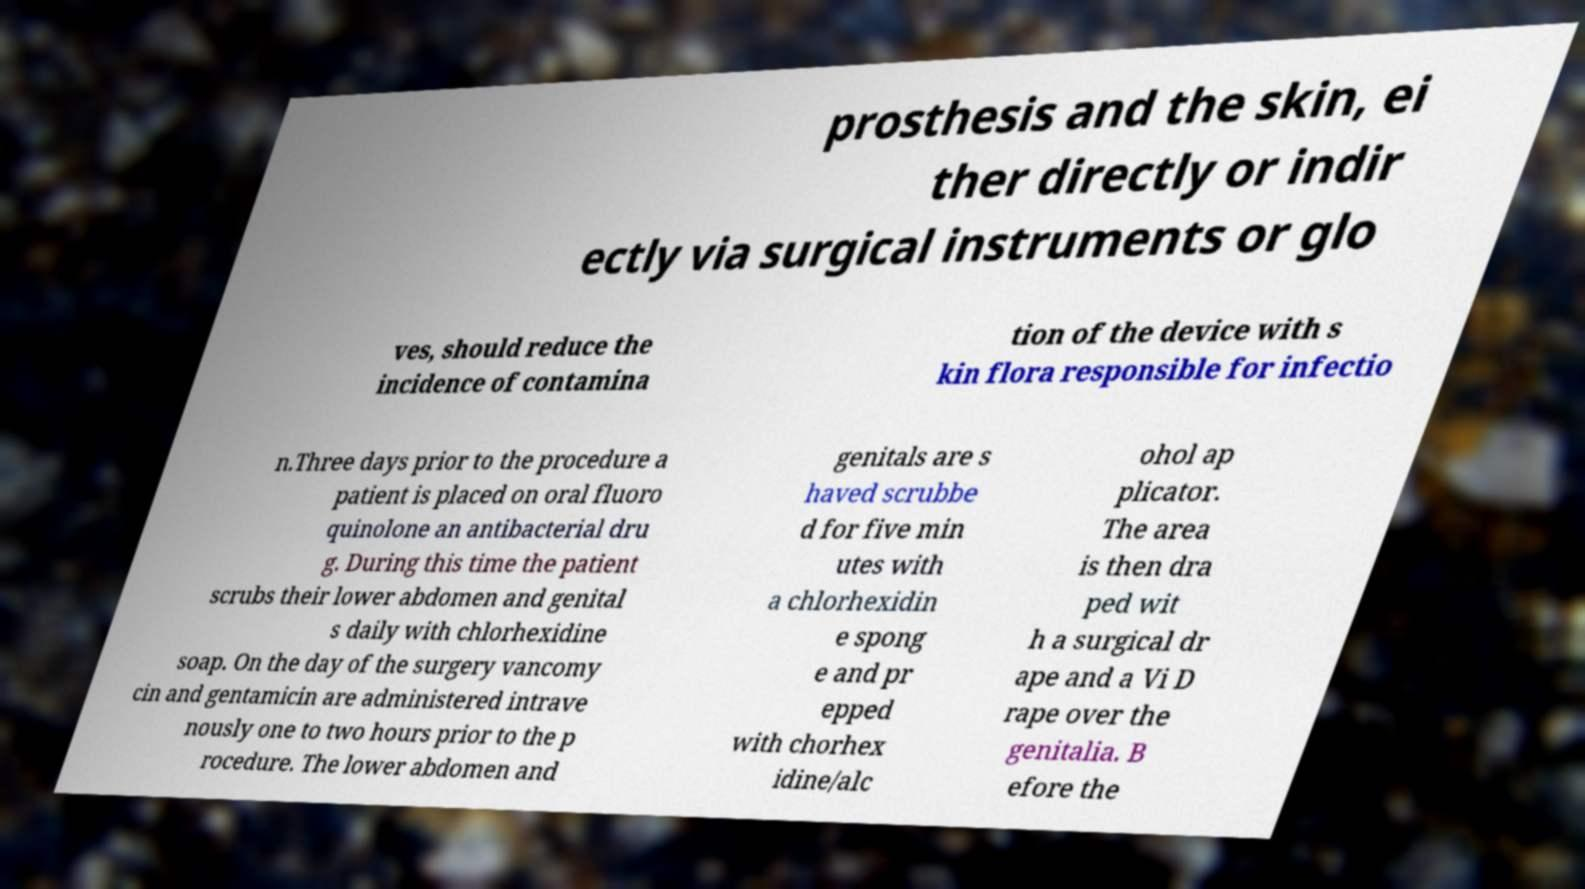What messages or text are displayed in this image? I need them in a readable, typed format. prosthesis and the skin, ei ther directly or indir ectly via surgical instruments or glo ves, should reduce the incidence of contamina tion of the device with s kin flora responsible for infectio n.Three days prior to the procedure a patient is placed on oral fluoro quinolone an antibacterial dru g. During this time the patient scrubs their lower abdomen and genital s daily with chlorhexidine soap. On the day of the surgery vancomy cin and gentamicin are administered intrave nously one to two hours prior to the p rocedure. The lower abdomen and genitals are s haved scrubbe d for five min utes with a chlorhexidin e spong e and pr epped with chorhex idine/alc ohol ap plicator. The area is then dra ped wit h a surgical dr ape and a Vi D rape over the genitalia. B efore the 